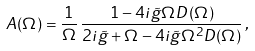Convert formula to latex. <formula><loc_0><loc_0><loc_500><loc_500>A ( \Omega ) = \frac { 1 } { \Omega } \, \frac { 1 - 4 i \tilde { g } \Omega D ( \Omega ) } { 2 i \tilde { g } + \Omega - 4 i \tilde { g } \Omega ^ { 2 } D ( \Omega ) } \, ,</formula> 